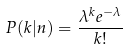Convert formula to latex. <formula><loc_0><loc_0><loc_500><loc_500>P ( k | n ) = \frac { \lambda ^ { k } e ^ { - \lambda } } { k ! }</formula> 